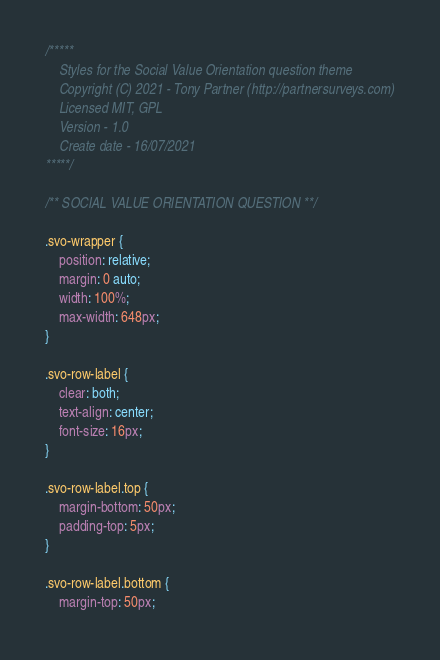Convert code to text. <code><loc_0><loc_0><loc_500><loc_500><_CSS_>
/***** 
    Styles for the Social Value Orientation question theme
    Copyright (C) 2021 - Tony Partner (http://partnersurveys.com)
    Licensed MIT, GPL
    Version - 1.0
    Create date - 16/07/2021
*****/

/** SOCIAL VALUE ORIENTATION QUESTION **/

.svo-wrapper {
	position: relative;
	margin: 0 auto;
	width: 100%;
	max-width: 648px;
}

.svo-row-label {
	clear: both;
	text-align: center;
	font-size: 16px;
}

.svo-row-label.top {
	margin-bottom: 50px;
	padding-top: 5px;
}

.svo-row-label.bottom {
	margin-top: 50px;</code> 